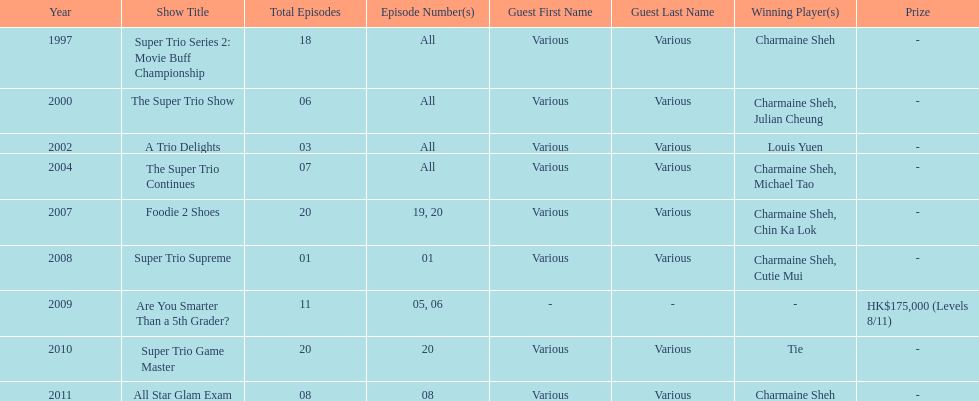How many consecutive trio shows did charmaine sheh do before being on another variety program? 34. 